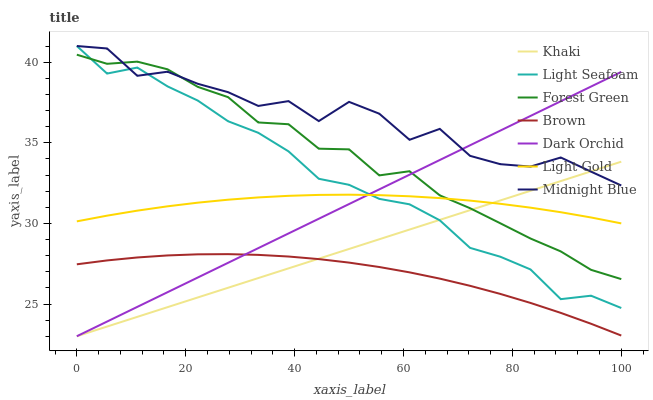Does Khaki have the minimum area under the curve?
Answer yes or no. No. Does Khaki have the maximum area under the curve?
Answer yes or no. No. Is Khaki the smoothest?
Answer yes or no. No. Is Khaki the roughest?
Answer yes or no. No. Does Midnight Blue have the lowest value?
Answer yes or no. No. Does Khaki have the highest value?
Answer yes or no. No. Is Light Gold less than Midnight Blue?
Answer yes or no. Yes. Is Light Gold greater than Brown?
Answer yes or no. Yes. Does Light Gold intersect Midnight Blue?
Answer yes or no. No. 